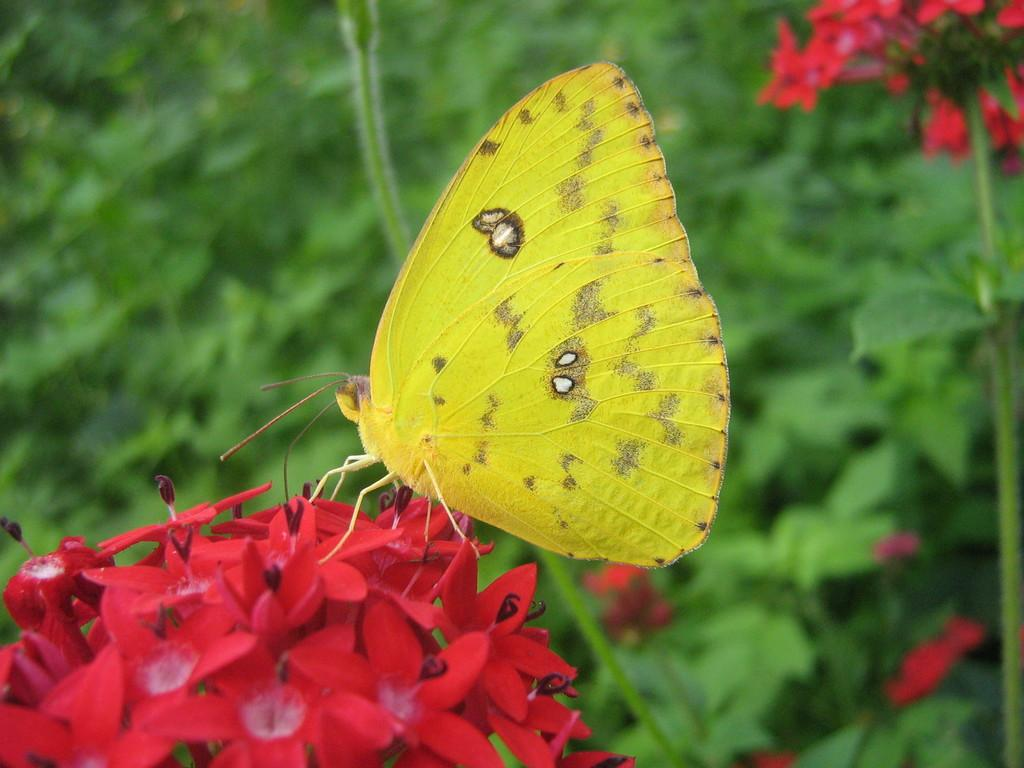What type of animal can be seen on the flowers in the image? There is a butterfly on the flowers in the image. What can be seen in the background of the image? There is greenery visible in the background of the image. How many trucks are parked behind the butterfly in the image? There are no trucks present in the image. What type of clothing is the butterfly wearing in the image? Butterflies do not wear clothing, so this question cannot be answered definitively from the image. 